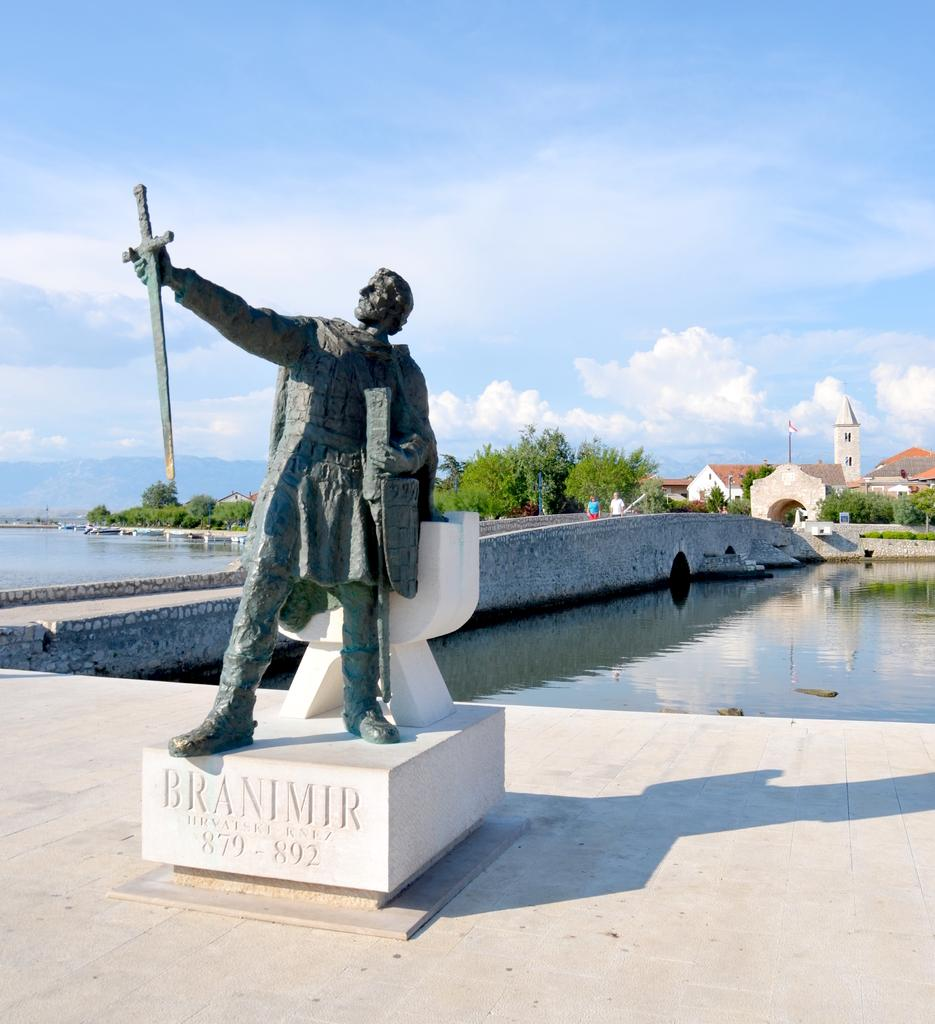What type of surface is visible in the image? There is a pavement in the image. What is located on the pavement? There is a statue on the pavement. What can be seen in the background of the image? There is a canal, a bridge, trees, and houses visible in the background of the image. What part of the natural environment is visible in the image? The sky is visible in the image. What type of business is being conducted on the statue in the image? There is no business being conducted on the statue in the image; it is a statue and not a location for business activities. 